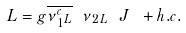<formula> <loc_0><loc_0><loc_500><loc_500>L = g \overline { \nu { _ { 1 } ^ { c } { _ { L } } } } \ \nu { _ { 2 } { _ { L } } } \ J \ + h . c .</formula> 